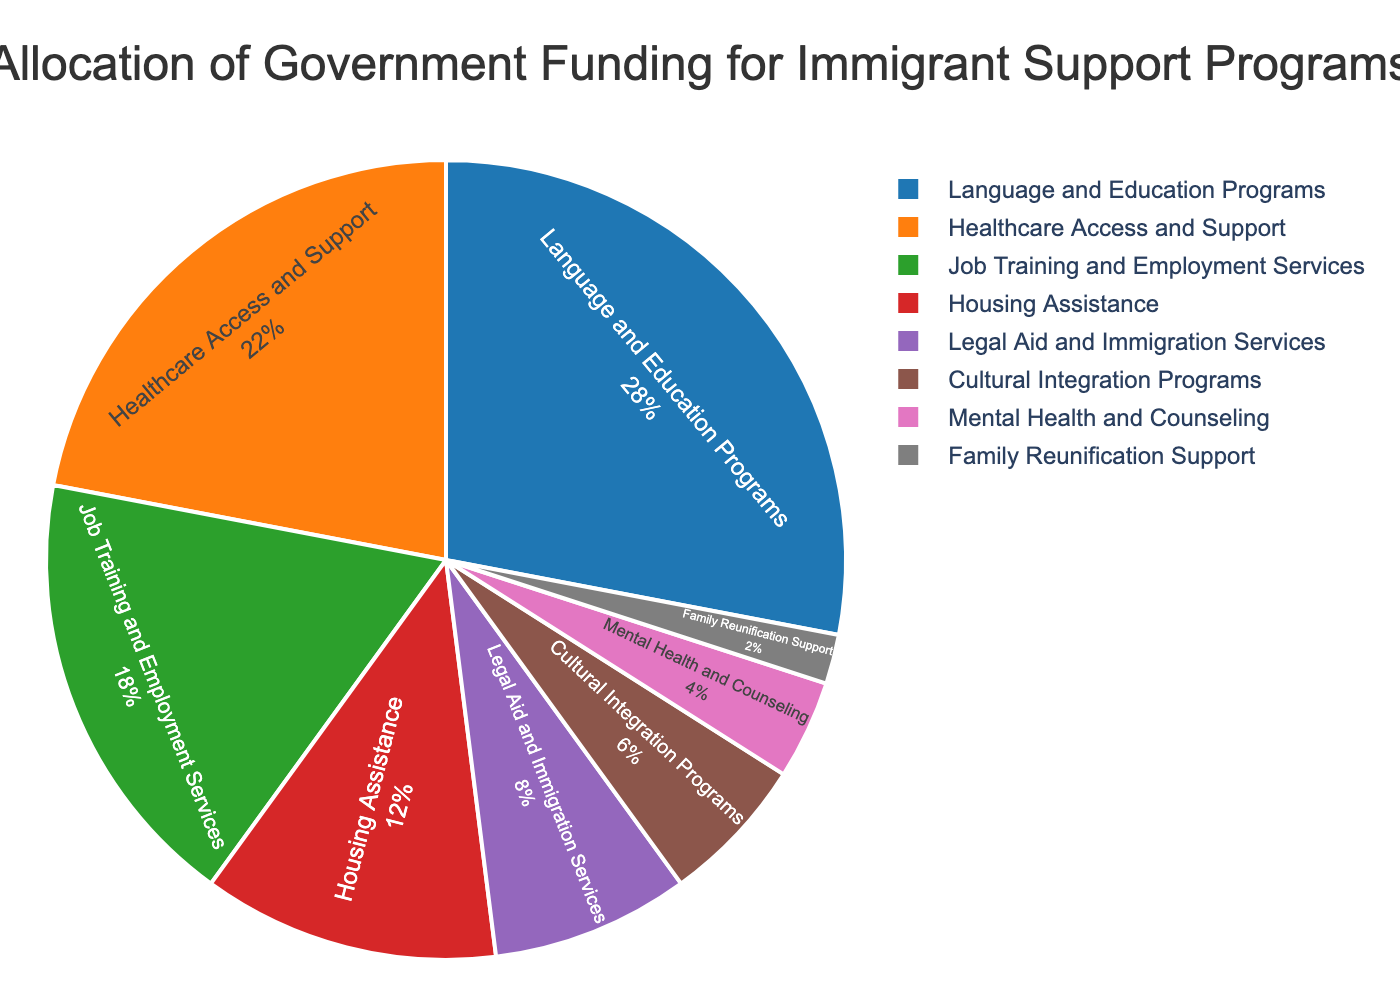Which category receives the highest percentage of government funding? First, identify the segment with the largest size in the pie chart. The largest segment represents the category with the highest percentage of funding.
Answer: Language and Education Programs How does the percentage allocated to Healthcare Access and Support compare to Mental Health and Counseling? Look for both segments in the pie chart and compare their respective sizes. Healthcare Access and Support has a larger segment than Mental Health and Counseling.
Answer: Healthcare Access and Support has a higher percentage What is the total percentage allocated to Job Training and Employment Services, Housing Assistance, and Legal Aid and Immigration Services combined? Sum the percentages for Job Training and Employment Services (18), Housing Assistance (12), and Legal Aid and Immigration Services (8). 18 + 12 + 8 = 38
Answer: 38 Which categories receive less than 10% of the total funding? Identify segments with percentages below 10% in the pie chart. These categories are Legal Aid and Immigration Services (8), Cultural Integration Programs (6), Mental Health and Counseling (4), and Family Reunification Support (2).
Answer: Legal Aid and Immigration Services, Cultural Integration Programs, Mental Health and Counseling, Family Reunification Support Which categories have a combined allocation equal to or greater than Cultural Integration Programs? Cultural Integration Programs receive 6%. Sum percentages for other categories to find combinations equal to/exceeding 6%.
Answer: Mental Health and Counseling (4) + Family Reunification Support (2) = 6; combined allocation is equal How much more funding is allocated to Language and Education Programs compared to Housing Assistance? Subtract the percentage for Housing Assistance from the percentage for Language and Education Programs. 28 - 12 = 16
Answer: 16 Which category's segment is represented in purple color in the pie chart? Visually identify the segment with purple color in the pie chart.
Answer: Cultural Integration Programs What is the visual representation of the smallest funded category? Look for the smallest segment in the pie chart, which usually has the smallest surface area. This corresponds to Family Reunification Support.
Answer: Smallest segment If Legal Aid and Immigration Services and Cultural Integration Programs were combined into one category, what would be their total percentage of funding? Add percentages for Legal Aid and Immigration Services (8) and Cultural Integration Programs (6). 8 + 6 = 14
Answer: 14 